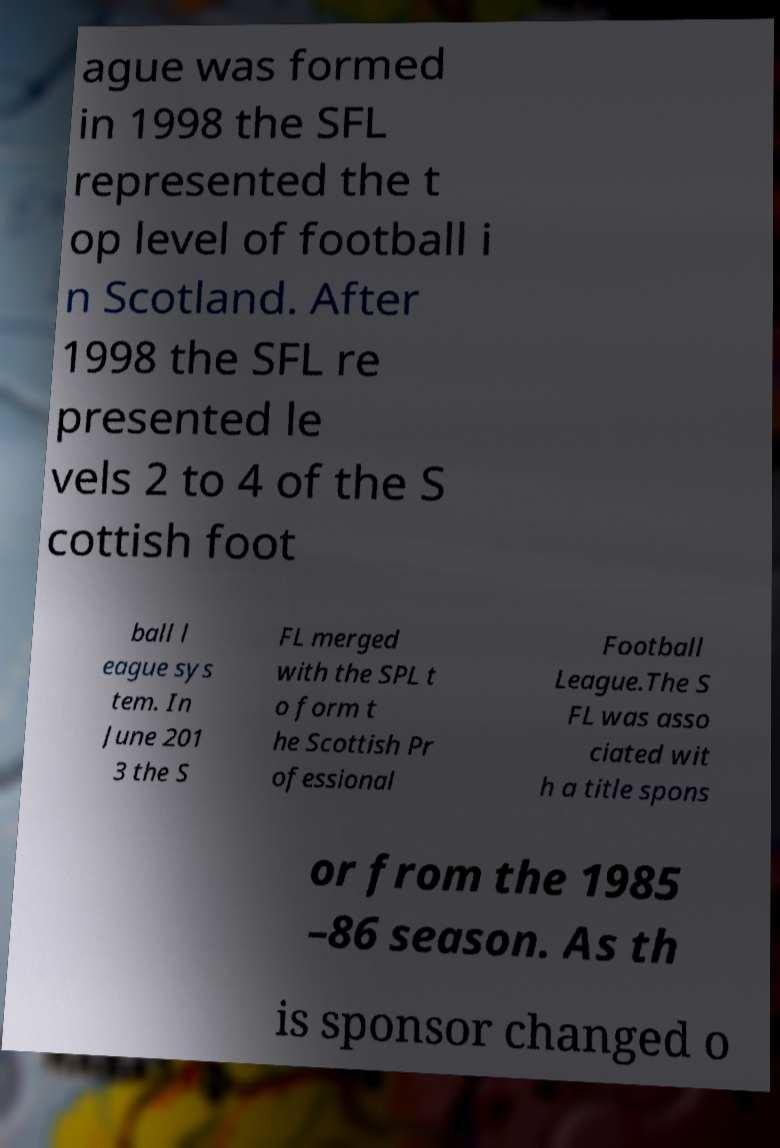Could you assist in decoding the text presented in this image and type it out clearly? ague was formed in 1998 the SFL represented the t op level of football i n Scotland. After 1998 the SFL re presented le vels 2 to 4 of the S cottish foot ball l eague sys tem. In June 201 3 the S FL merged with the SPL t o form t he Scottish Pr ofessional Football League.The S FL was asso ciated wit h a title spons or from the 1985 –86 season. As th is sponsor changed o 